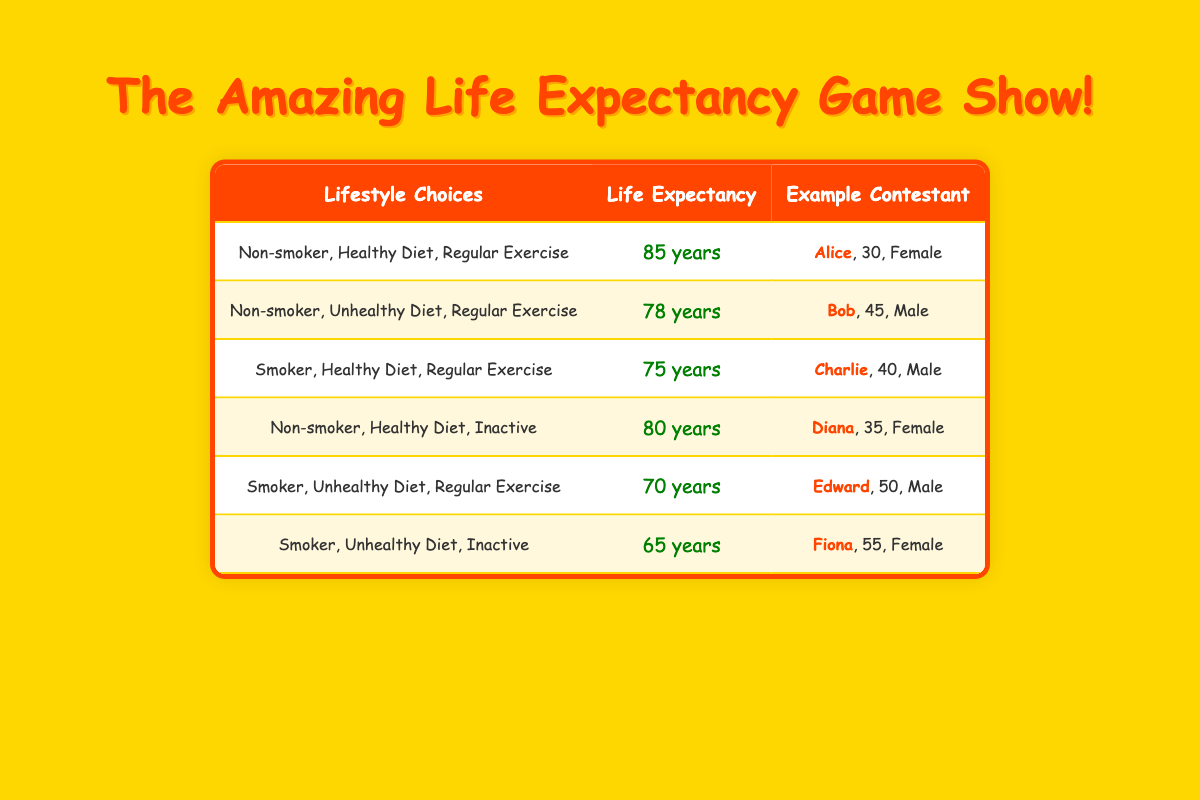What is the life expectancy for a non-smoker with a healthy diet and regular exercise? According to the table, the life expectancy for this lifestyle choice is listed directly under that category. It shows "85 years".
Answer: 85 years What is the life expectancy for someone who smokes, has an unhealthy diet, and is inactive? From the table, the specific lifestyle choice states that the corresponding life expectancy is provided clearly in that row, which is "65 years".
Answer: 65 years Who is the person with the longest life expectancy? To find this, we look through each row's life expectancy and notice that Alice, living a non-smoker, healthy diet, and regular exercise lifestyle, has the highest life expectancy of "85 years".
Answer: Alice Is there a lifestyle choice that combines being a non-smoker and having an unhealthy diet? After reviewing the table, it can be observed that there is a lifestyle choice "Non-smoker, Unhealthy Diet, Regular Exercise" for Bob, confirming the existence of this combination.
Answer: Yes What is the average life expectancy of all the contestants? First, add together all life expectancies: 85 + 78 + 75 + 80 + 70 + 65 = 453. There are 6 contestants, so dividing gives: 453 / 6 = 75.5. Hence, the average life expectancy is 75.5 years.
Answer: 75.5 years Which contestant is 55 years old and what is her life expectancy? Looking at the table, Fiona is identified as the 55-year-old contestant with the lifestyle "Smoker, Unhealthy Diet, Inactive", and her life expectancy is noted as "65 years".
Answer: Fiona, 65 years If someone exercises regularly but has an unhealthy diet, how does their life expectancy compare to a smoker with a healthy diet? The life expectancy for "Smoker, Healthy Diet, Regular Exercise" is 75 years, while "Non-smoker, Unhealthy Diet, Regular Exercise" is 78 years. Hence, we find that the non-smoker is expected to live 3 years longer.
Answer: Non-smoker lives 3 years longer Does having a healthy diet impact life expectancy positively across all groups? Reviewing the options, we see comparisons for non-smokers versus smokers with healthy diets resulting in higher life expectancy numbers, while unhealthy diets reveal lesser life expectancy. Thus, the answer is consistent.
Answer: Yes 